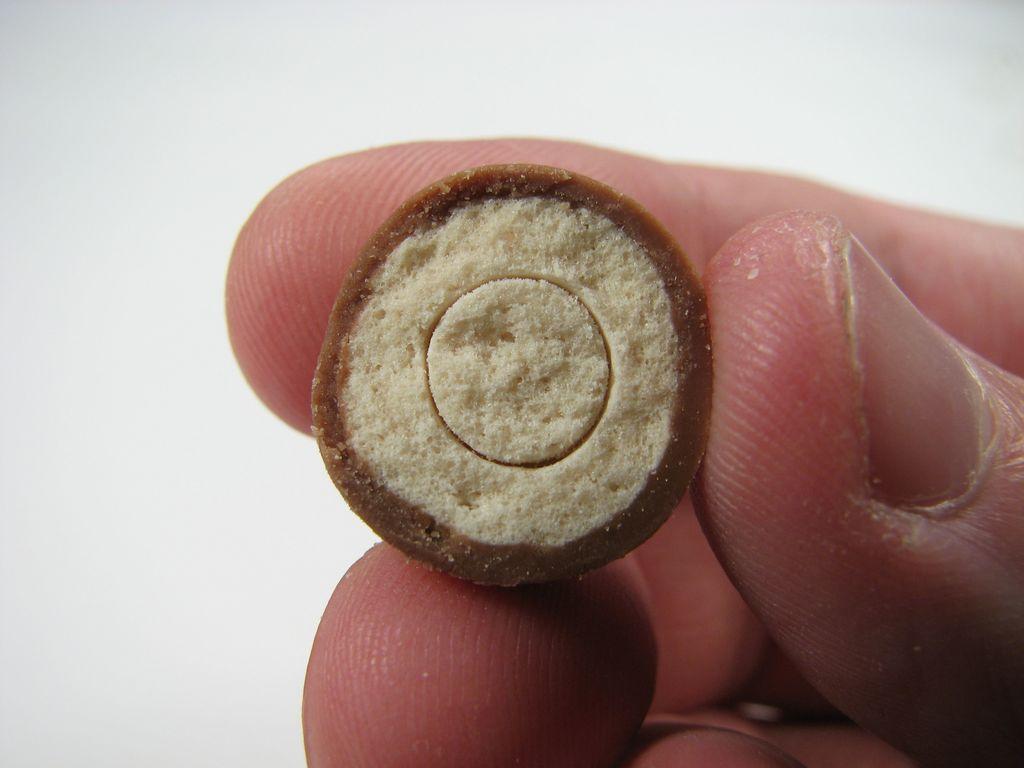Can you describe this image briefly? In this image we can see fingers of a person holding an object. There is a white background. 